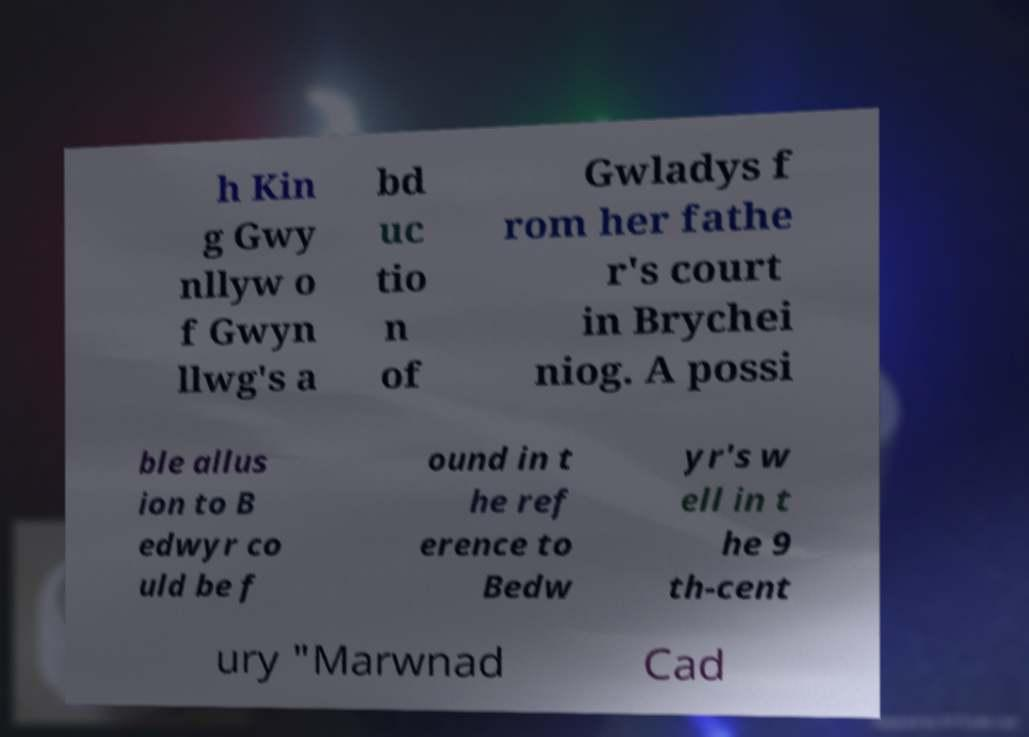I need the written content from this picture converted into text. Can you do that? h Kin g Gwy nllyw o f Gwyn llwg's a bd uc tio n of Gwladys f rom her fathe r's court in Brychei niog. A possi ble allus ion to B edwyr co uld be f ound in t he ref erence to Bedw yr's w ell in t he 9 th-cent ury "Marwnad Cad 